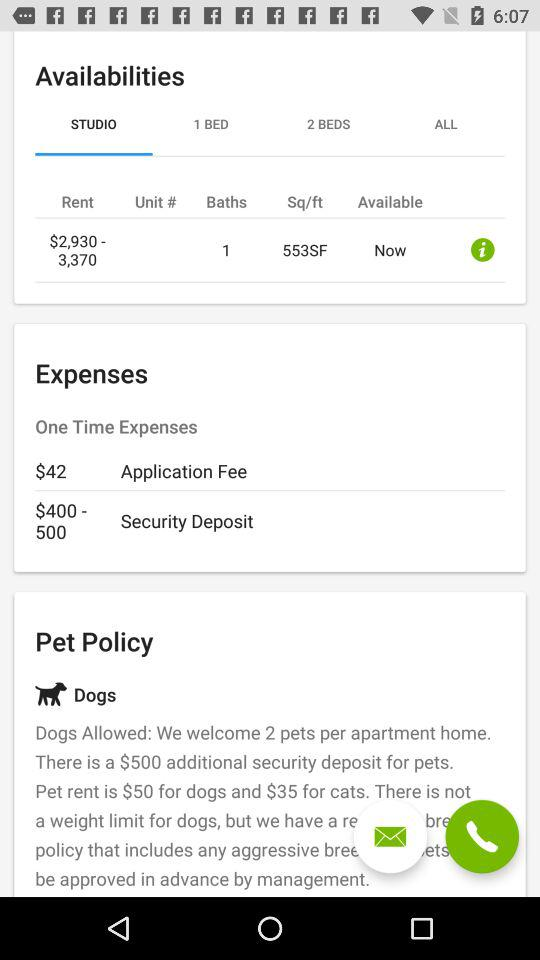What is the area? The area is 553 square feet. 